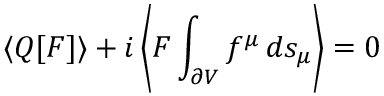<formula> <loc_0><loc_0><loc_500><loc_500>\langle Q [ F ] \rangle + i \left \langle F \int _ { \partial V } f ^ { \mu } \, d s _ { \mu } \right \rangle = 0</formula> 